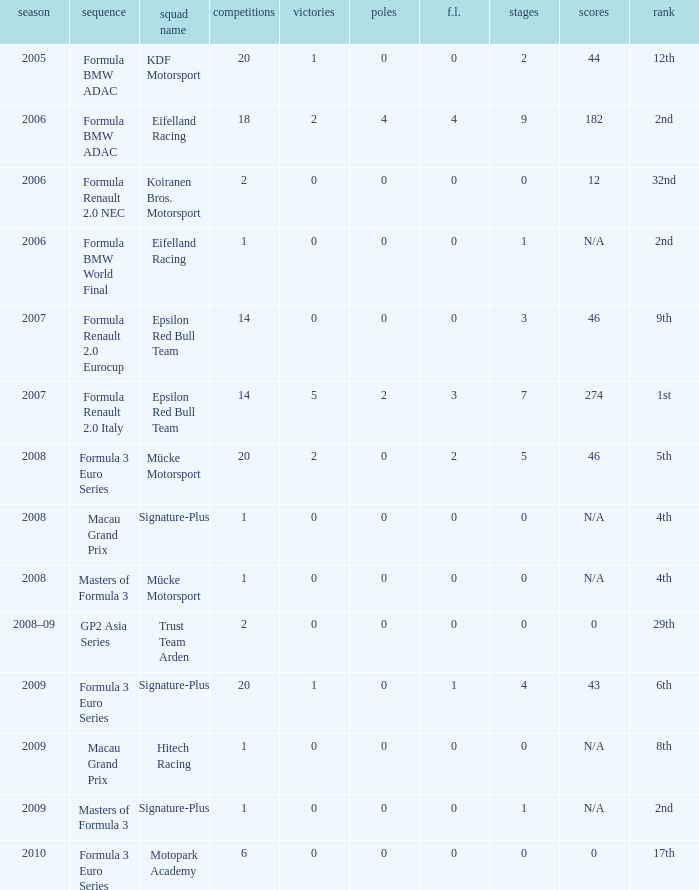What is the average number of podiums in the 32nd position with less than 0 wins? None. 